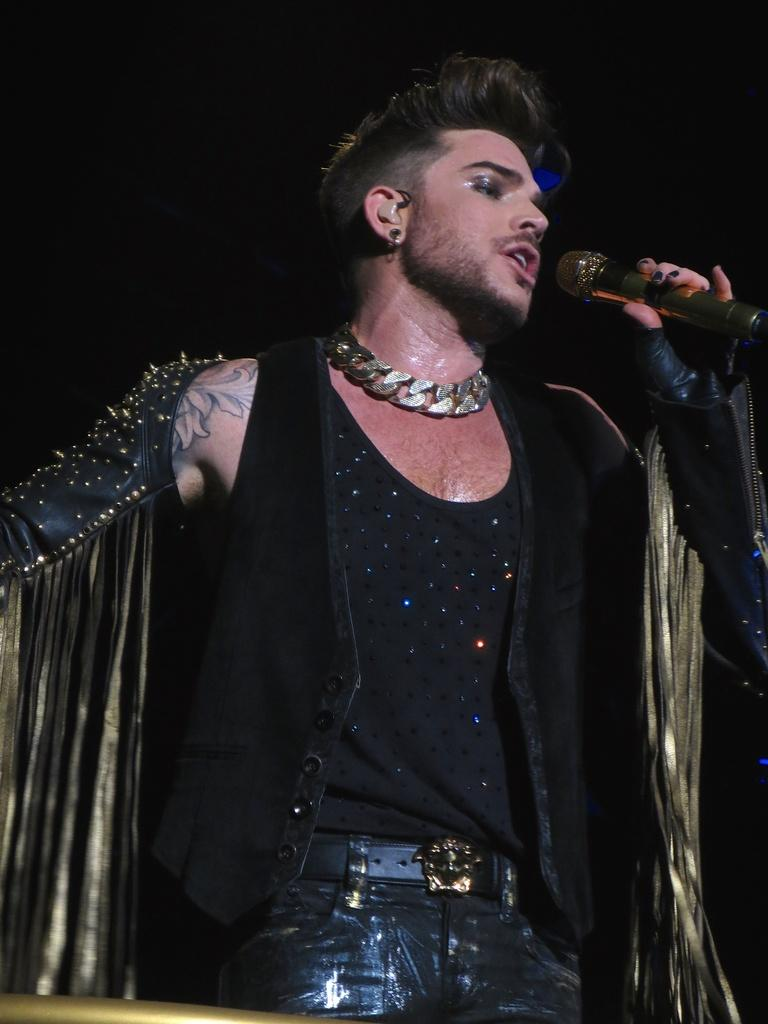Who is the main subject in the image? There is a boy in the image. What is the boy wearing? The boy is wearing a black shirt. What object is the boy holding in his hand? The boy is holding a microphone in his hand. What activity is the boy engaged in? The boy is singing. What type of error can be seen in the image? There is no error present in the image; it features a boy singing while holding a microphone. How many birds are visible in the image? There are no birds visible in the image. 